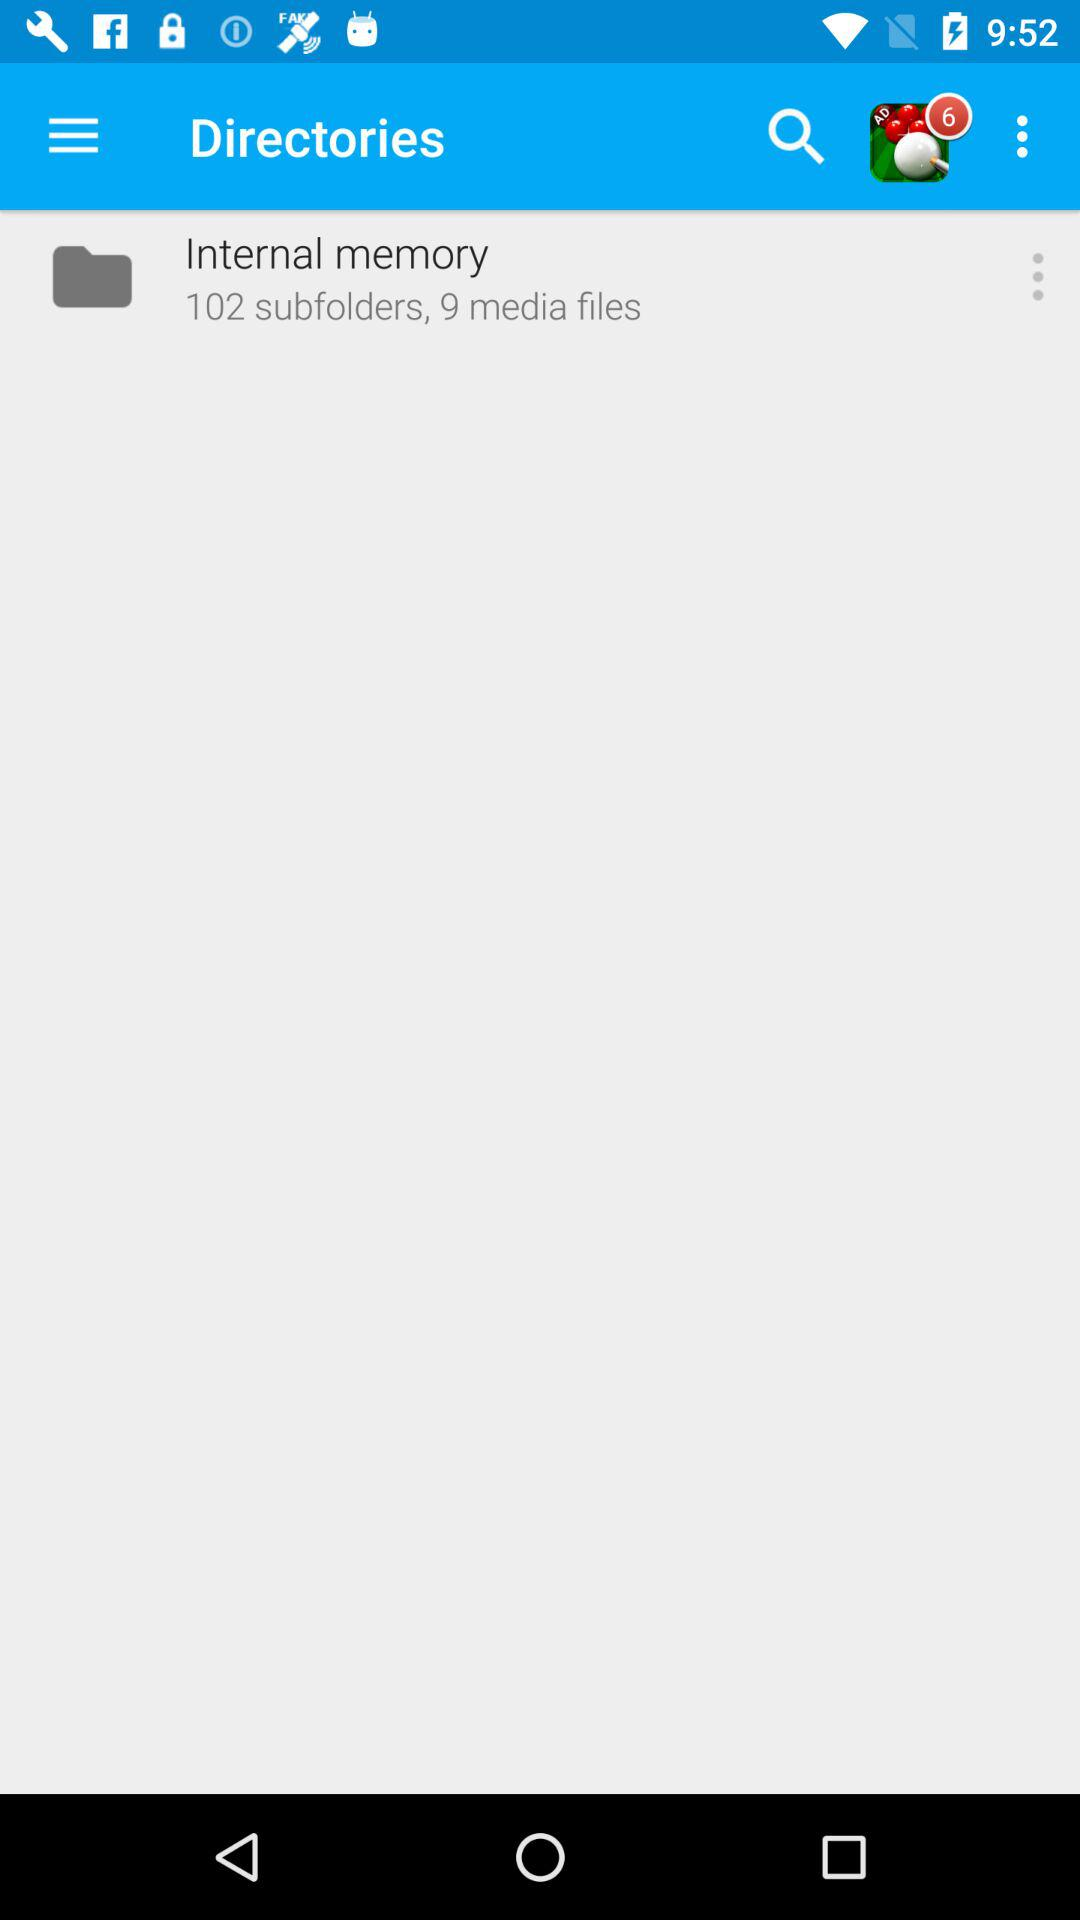What is the total number of notifications shown? There are 6 notifications. 